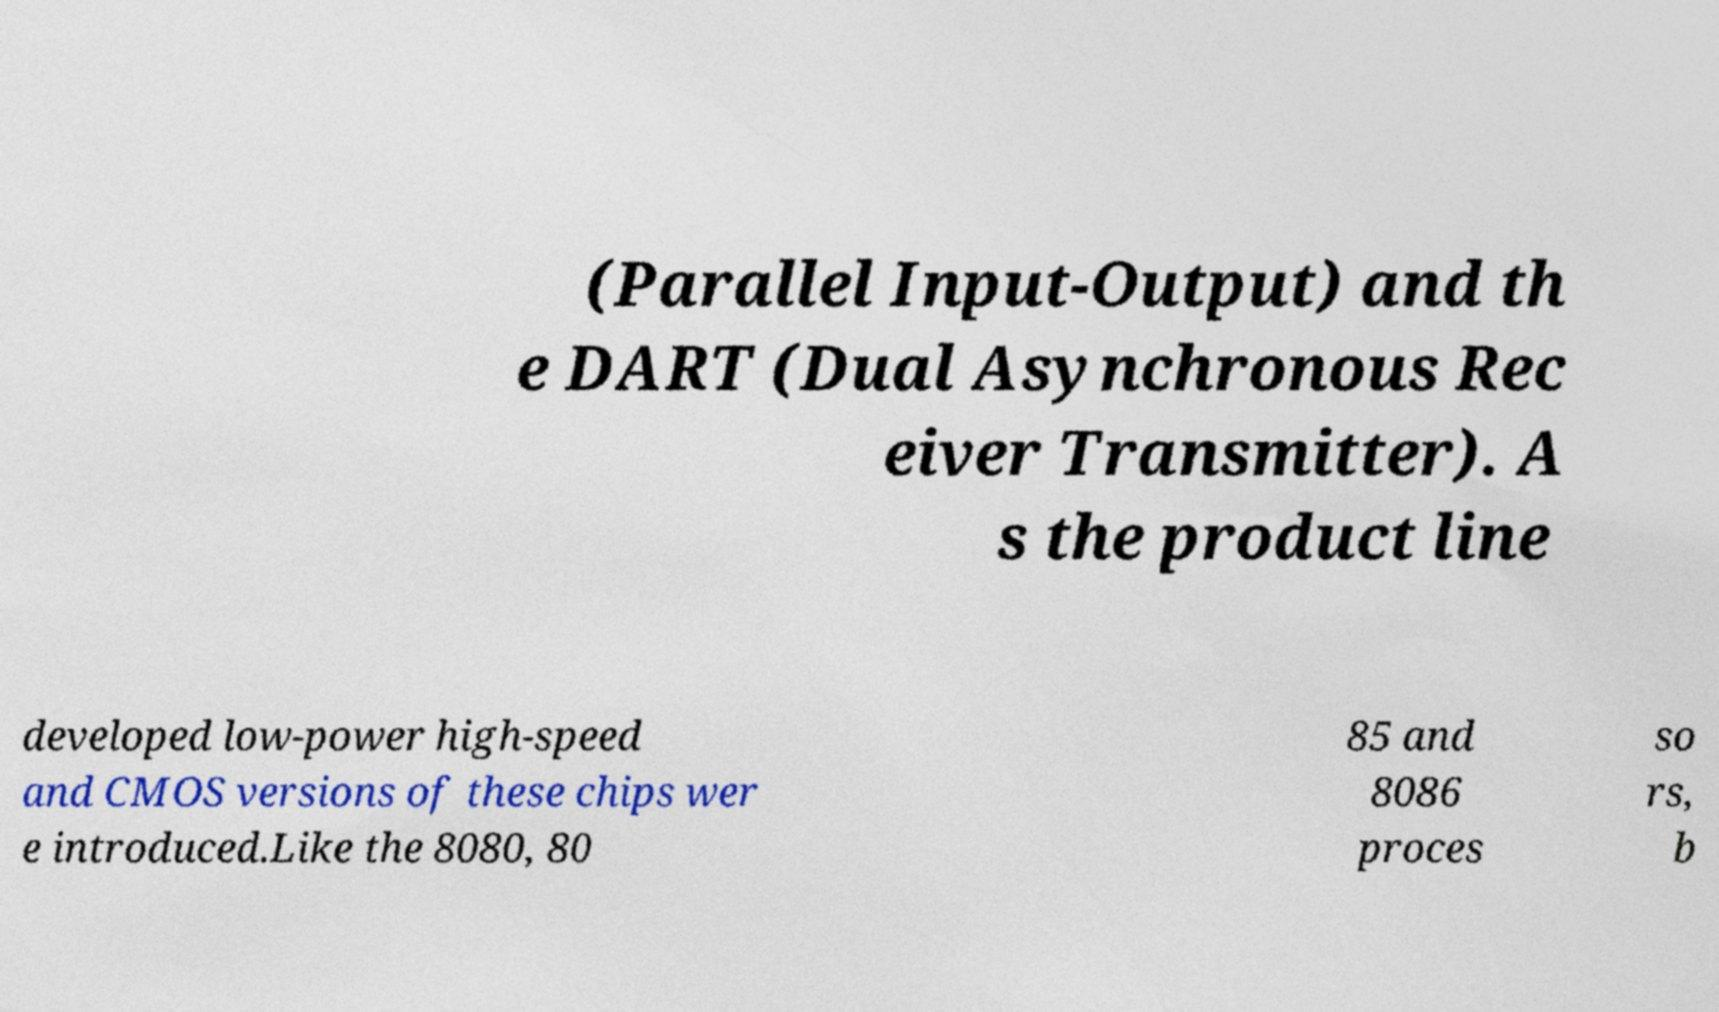What messages or text are displayed in this image? I need them in a readable, typed format. (Parallel Input-Output) and th e DART (Dual Asynchronous Rec eiver Transmitter). A s the product line developed low-power high-speed and CMOS versions of these chips wer e introduced.Like the 8080, 80 85 and 8086 proces so rs, b 